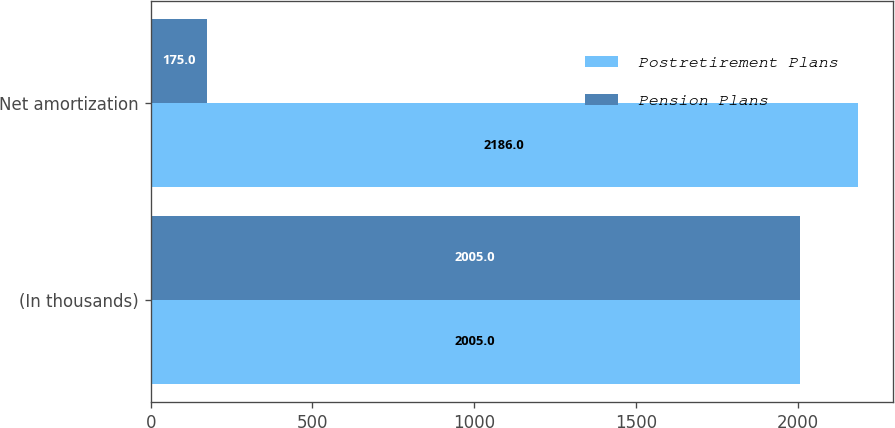Convert chart. <chart><loc_0><loc_0><loc_500><loc_500><stacked_bar_chart><ecel><fcel>(In thousands)<fcel>Net amortization<nl><fcel>Postretirement Plans<fcel>2005<fcel>2186<nl><fcel>Pension Plans<fcel>2005<fcel>175<nl></chart> 